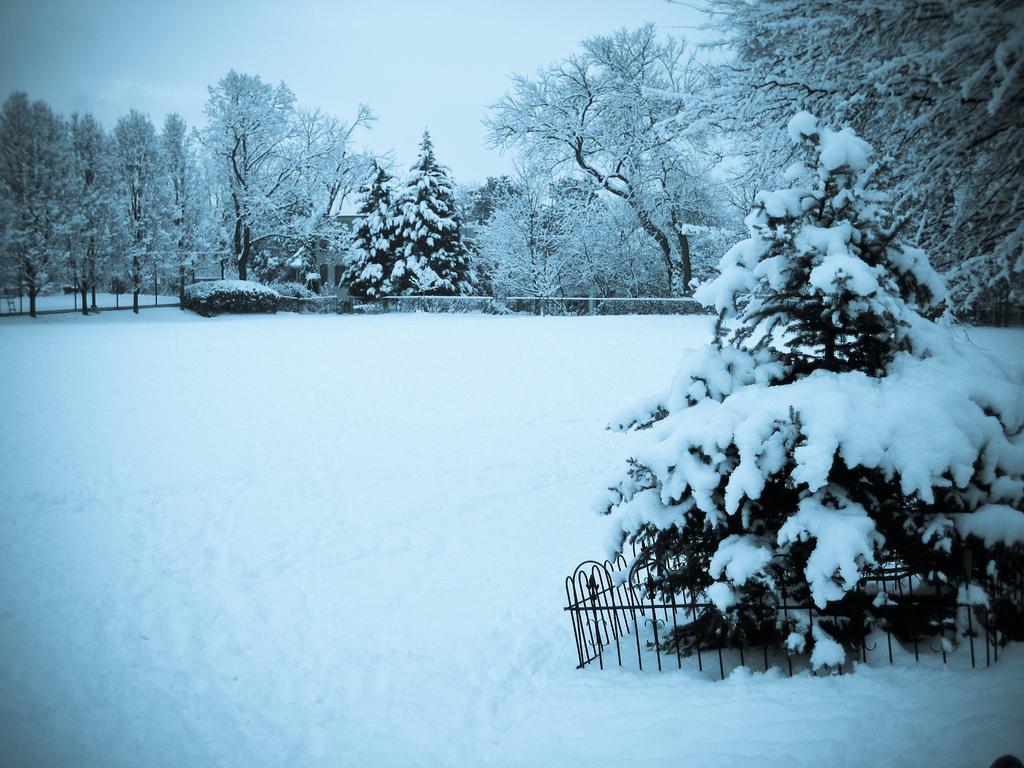Could you give a brief overview of what you see in this image? In this image there are trees covered by snow. At the bottom there is snow and we can see grilles. In the background there is sky. 